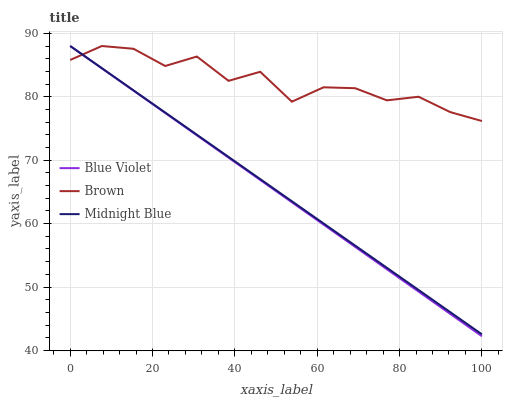Does Blue Violet have the minimum area under the curve?
Answer yes or no. Yes. Does Brown have the maximum area under the curve?
Answer yes or no. Yes. Does Midnight Blue have the minimum area under the curve?
Answer yes or no. No. Does Midnight Blue have the maximum area under the curve?
Answer yes or no. No. Is Midnight Blue the smoothest?
Answer yes or no. Yes. Is Brown the roughest?
Answer yes or no. Yes. Is Blue Violet the smoothest?
Answer yes or no. No. Is Blue Violet the roughest?
Answer yes or no. No. Does Midnight Blue have the lowest value?
Answer yes or no. No. 